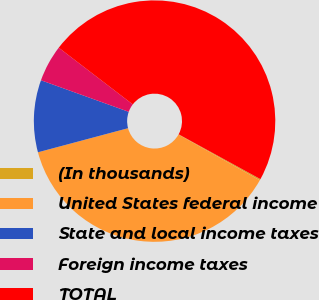Convert chart to OTSL. <chart><loc_0><loc_0><loc_500><loc_500><pie_chart><fcel>(In thousands)<fcel>United States federal income<fcel>State and local income taxes<fcel>Foreign income taxes<fcel>TOTAL<nl><fcel>0.17%<fcel>37.69%<fcel>9.65%<fcel>4.91%<fcel>47.57%<nl></chart> 